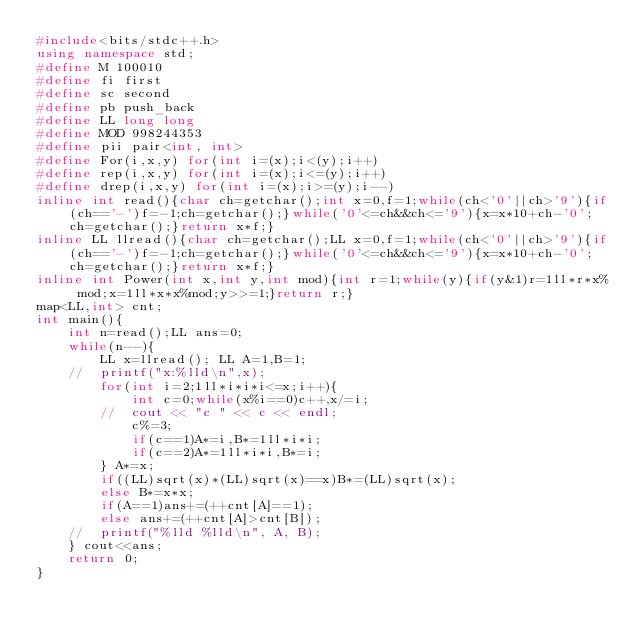<code> <loc_0><loc_0><loc_500><loc_500><_C++_>#include<bits/stdc++.h>
using namespace std;
#define M 100010
#define fi first
#define sc second
#define pb push_back
#define LL long long
#define MOD 998244353
#define pii pair<int, int>
#define For(i,x,y) for(int i=(x);i<(y);i++)
#define rep(i,x,y) for(int i=(x);i<=(y);i++)
#define drep(i,x,y) for(int i=(x);i>=(y);i--)
inline int read(){char ch=getchar();int x=0,f=1;while(ch<'0'||ch>'9'){if(ch=='-')f=-1;ch=getchar();}while('0'<=ch&&ch<='9'){x=x*10+ch-'0';ch=getchar();}return x*f;}
inline LL llread(){char ch=getchar();LL x=0,f=1;while(ch<'0'||ch>'9'){if(ch=='-')f=-1;ch=getchar();}while('0'<=ch&&ch<='9'){x=x*10+ch-'0';ch=getchar();}return x*f;}
inline int Power(int x,int y,int mod){int r=1;while(y){if(y&1)r=1ll*r*x% mod;x=1ll*x*x%mod;y>>=1;}return r;}
map<LL,int> cnt;
int main(){
	int n=read();LL ans=0;
	while(n--){
		LL x=llread(); LL A=1,B=1;
	//	printf("x:%lld\n",x);
		for(int i=2;1ll*i*i*i<=x;i++){
			int c=0;while(x%i==0)c++,x/=i;
		//	cout << "c " << c << endl;
			c%=3;
			if(c==1)A*=i,B*=1ll*i*i;
			if(c==2)A*=1ll*i*i,B*=i;
		} A*=x;
		if((LL)sqrt(x)*(LL)sqrt(x)==x)B*=(LL)sqrt(x);
		else B*=x*x;
		if(A==1)ans+=(++cnt[A]==1);
		else ans+=(++cnt[A]>cnt[B]);
	//	printf("%lld %lld\n", A, B);
	} cout<<ans;
	return 0;
}</code> 